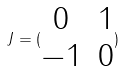Convert formula to latex. <formula><loc_0><loc_0><loc_500><loc_500>J = ( \begin{matrix} 0 & 1 \\ - 1 & 0 \end{matrix} )</formula> 